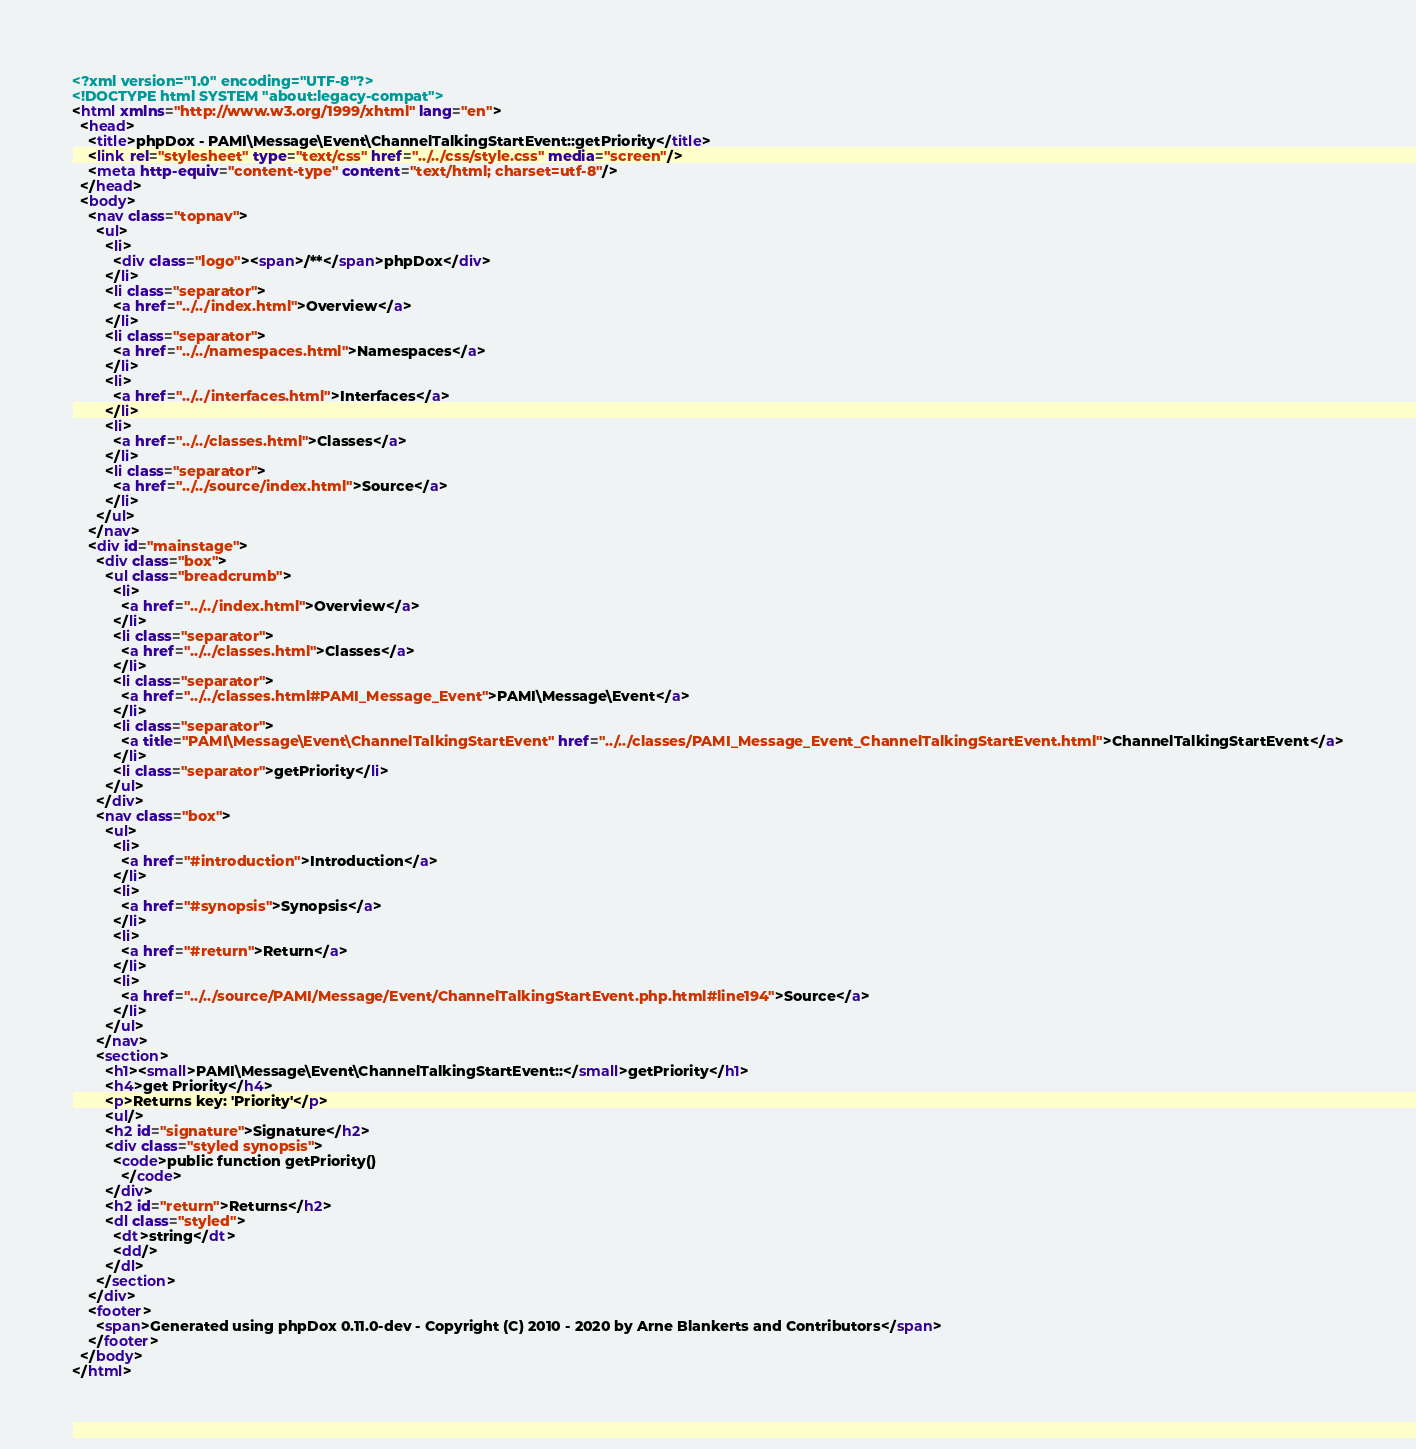Convert code to text. <code><loc_0><loc_0><loc_500><loc_500><_HTML_><?xml version="1.0" encoding="UTF-8"?>
<!DOCTYPE html SYSTEM "about:legacy-compat">
<html xmlns="http://www.w3.org/1999/xhtml" lang="en">
  <head>
    <title>phpDox - PAMI\Message\Event\ChannelTalkingStartEvent::getPriority</title>
    <link rel="stylesheet" type="text/css" href="../../css/style.css" media="screen"/>
    <meta http-equiv="content-type" content="text/html; charset=utf-8"/>
  </head>
  <body>
    <nav class="topnav">
      <ul>
        <li>
          <div class="logo"><span>/**</span>phpDox</div>
        </li>
        <li class="separator">
          <a href="../../index.html">Overview</a>
        </li>
        <li class="separator">
          <a href="../../namespaces.html">Namespaces</a>
        </li>
        <li>
          <a href="../../interfaces.html">Interfaces</a>
        </li>
        <li>
          <a href="../../classes.html">Classes</a>
        </li>
        <li class="separator">
          <a href="../../source/index.html">Source</a>
        </li>
      </ul>
    </nav>
    <div id="mainstage">
      <div class="box">
        <ul class="breadcrumb">
          <li>
            <a href="../../index.html">Overview</a>
          </li>
          <li class="separator">
            <a href="../../classes.html">Classes</a>
          </li>
          <li class="separator">
            <a href="../../classes.html#PAMI_Message_Event">PAMI\Message\Event</a>
          </li>
          <li class="separator">
            <a title="PAMI\Message\Event\ChannelTalkingStartEvent" href="../../classes/PAMI_Message_Event_ChannelTalkingStartEvent.html">ChannelTalkingStartEvent</a>
          </li>
          <li class="separator">getPriority</li>
        </ul>
      </div>
      <nav class="box">
        <ul>
          <li>
            <a href="#introduction">Introduction</a>
          </li>
          <li>
            <a href="#synopsis">Synopsis</a>
          </li>
          <li>
            <a href="#return">Return</a>
          </li>
          <li>
            <a href="../../source/PAMI/Message/Event/ChannelTalkingStartEvent.php.html#line194">Source</a>
          </li>
        </ul>
      </nav>
      <section>
        <h1><small>PAMI\Message\Event\ChannelTalkingStartEvent::</small>getPriority</h1>
        <h4>get Priority</h4>
        <p>Returns key: 'Priority'</p>
        <ul/>
        <h2 id="signature">Signature</h2>
        <div class="styled synopsis">
          <code>public function getPriority()
            </code>
        </div>
        <h2 id="return">Returns</h2>
        <dl class="styled">
          <dt>string</dt>
          <dd/>
        </dl>
      </section>
    </div>
    <footer>
      <span>Generated using phpDox 0.11.0-dev - Copyright (C) 2010 - 2020 by Arne Blankerts and Contributors</span>
    </footer>
  </body>
</html>
</code> 